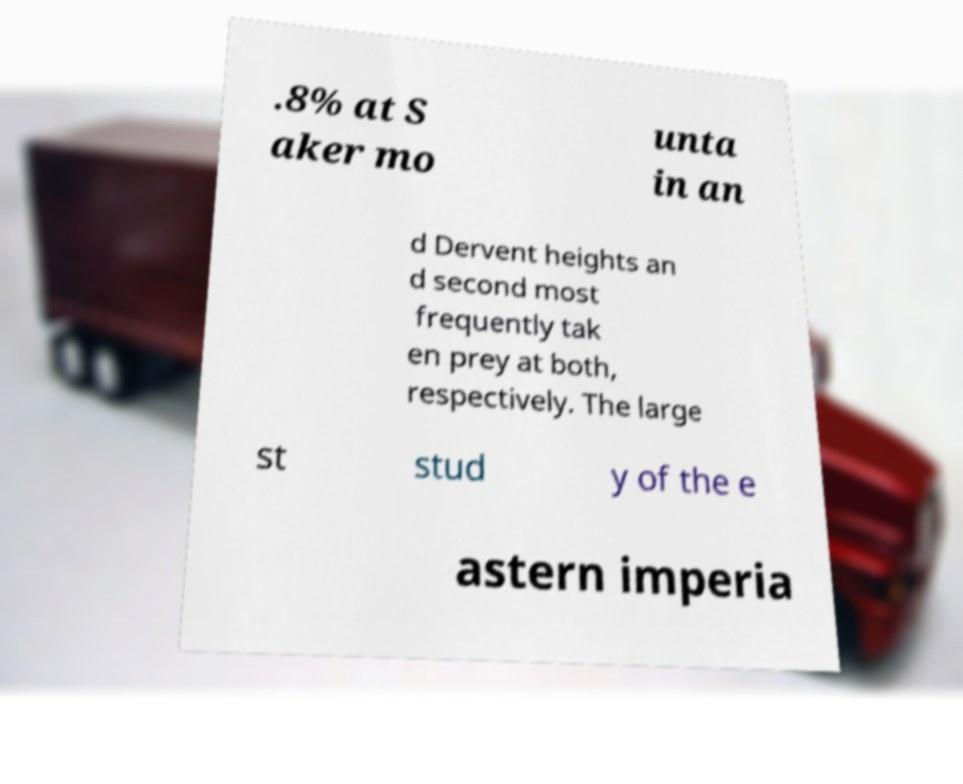I need the written content from this picture converted into text. Can you do that? .8% at S aker mo unta in an d Dervent heights an d second most frequently tak en prey at both, respectively. The large st stud y of the e astern imperia 